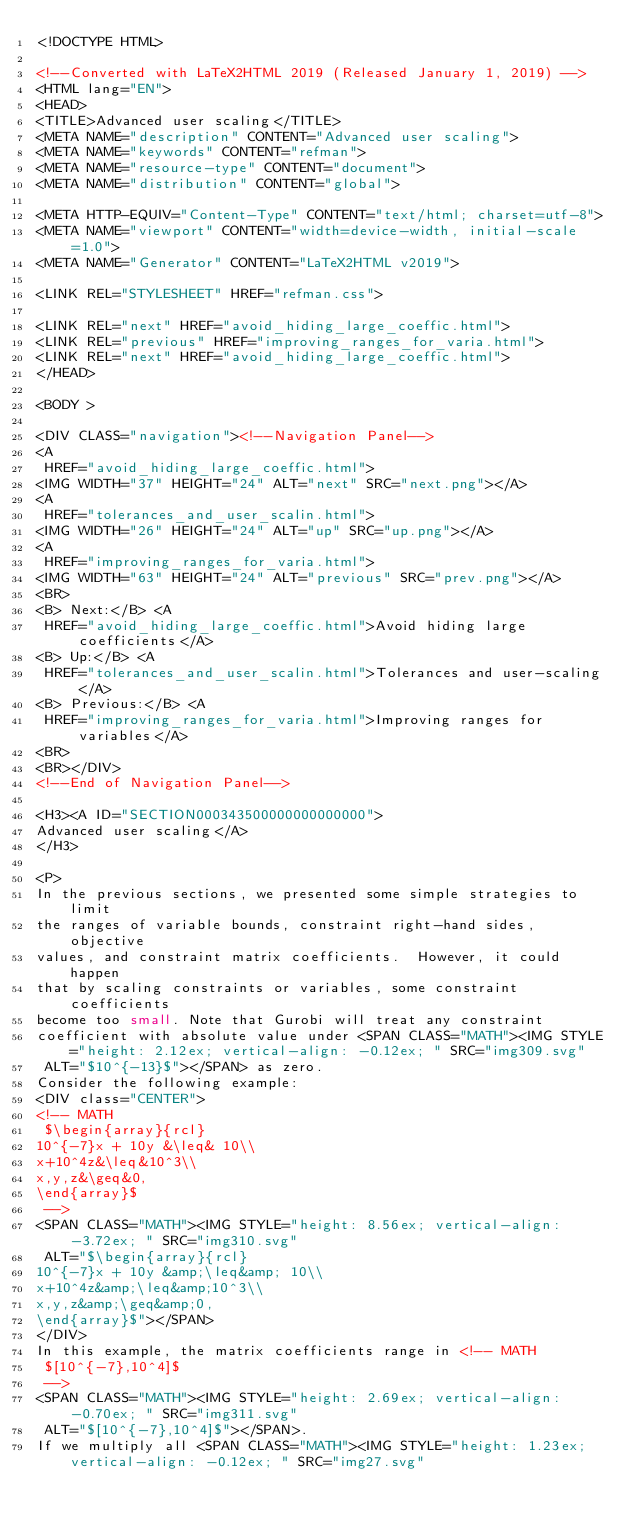<code> <loc_0><loc_0><loc_500><loc_500><_HTML_><!DOCTYPE HTML>

<!--Converted with LaTeX2HTML 2019 (Released January 1, 2019) -->
<HTML lang="EN">
<HEAD>
<TITLE>Advanced user scaling</TITLE>
<META NAME="description" CONTENT="Advanced user scaling">
<META NAME="keywords" CONTENT="refman">
<META NAME="resource-type" CONTENT="document">
<META NAME="distribution" CONTENT="global">

<META HTTP-EQUIV="Content-Type" CONTENT="text/html; charset=utf-8">
<META NAME="viewport" CONTENT="width=device-width, initial-scale=1.0">
<META NAME="Generator" CONTENT="LaTeX2HTML v2019">

<LINK REL="STYLESHEET" HREF="refman.css">

<LINK REL="next" HREF="avoid_hiding_large_coeffic.html">
<LINK REL="previous" HREF="improving_ranges_for_varia.html">
<LINK REL="next" HREF="avoid_hiding_large_coeffic.html">
</HEAD>

<BODY >

<DIV CLASS="navigation"><!--Navigation Panel-->
<A
 HREF="avoid_hiding_large_coeffic.html">
<IMG WIDTH="37" HEIGHT="24" ALT="next" SRC="next.png"></A> 
<A
 HREF="tolerances_and_user_scalin.html">
<IMG WIDTH="26" HEIGHT="24" ALT="up" SRC="up.png"></A> 
<A
 HREF="improving_ranges_for_varia.html">
<IMG WIDTH="63" HEIGHT="24" ALT="previous" SRC="prev.png"></A>   
<BR>
<B> Next:</B> <A
 HREF="avoid_hiding_large_coeffic.html">Avoid hiding large coefficients</A>
<B> Up:</B> <A
 HREF="tolerances_and_user_scalin.html">Tolerances and user-scaling</A>
<B> Previous:</B> <A
 HREF="improving_ranges_for_varia.html">Improving ranges for variables</A>
<BR>
<BR></DIV>
<!--End of Navigation Panel-->

<H3><A ID="SECTION000343500000000000000">
Advanced user scaling</A>
</H3>

<P>
In the previous sections, we presented some simple strategies to limit
the ranges of variable bounds, constraint right-hand sides, objective
values, and constraint matrix coefficients.  However, it could happen
that by scaling constraints or variables, some constraint coefficients
become too small. Note that Gurobi will treat any constraint
coefficient with absolute value under <SPAN CLASS="MATH"><IMG STYLE="height: 2.12ex; vertical-align: -0.12ex; " SRC="img309.svg"
 ALT="$10^{-13}$"></SPAN> as zero.
Consider the following example:
<DIV class="CENTER">
<!-- MATH
 $\begin{array}{rcl}
10^{-7}x + 10y &\leq& 10\\
x+10^4z&\leq&10^3\\
x,y,z&\geq&0,
\end{array}$
 -->
<SPAN CLASS="MATH"><IMG STYLE="height: 8.56ex; vertical-align: -3.72ex; " SRC="img310.svg"
 ALT="$\begin{array}{rcl}
10^{-7}x + 10y &amp;\leq&amp; 10\\
x+10^4z&amp;\leq&amp;10^3\\
x,y,z&amp;\geq&amp;0,
\end{array}$"></SPAN>
</DIV>
In this example, the matrix coefficients range in <!-- MATH
 $[10^{-7},10^4]$
 -->
<SPAN CLASS="MATH"><IMG STYLE="height: 2.69ex; vertical-align: -0.70ex; " SRC="img311.svg"
 ALT="$[10^{-7},10^4]$"></SPAN>.
If we multiply all <SPAN CLASS="MATH"><IMG STYLE="height: 1.23ex; vertical-align: -0.12ex; " SRC="img27.svg"</code> 